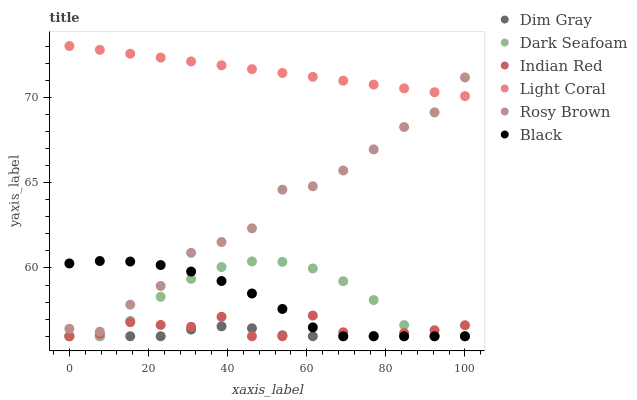Does Dim Gray have the minimum area under the curve?
Answer yes or no. Yes. Does Light Coral have the maximum area under the curve?
Answer yes or no. Yes. Does Rosy Brown have the minimum area under the curve?
Answer yes or no. No. Does Rosy Brown have the maximum area under the curve?
Answer yes or no. No. Is Light Coral the smoothest?
Answer yes or no. Yes. Is Rosy Brown the roughest?
Answer yes or no. Yes. Is Rosy Brown the smoothest?
Answer yes or no. No. Is Light Coral the roughest?
Answer yes or no. No. Does Dim Gray have the lowest value?
Answer yes or no. Yes. Does Rosy Brown have the lowest value?
Answer yes or no. No. Does Light Coral have the highest value?
Answer yes or no. Yes. Does Rosy Brown have the highest value?
Answer yes or no. No. Is Dim Gray less than Rosy Brown?
Answer yes or no. Yes. Is Rosy Brown greater than Indian Red?
Answer yes or no. Yes. Does Black intersect Dark Seafoam?
Answer yes or no. Yes. Is Black less than Dark Seafoam?
Answer yes or no. No. Is Black greater than Dark Seafoam?
Answer yes or no. No. Does Dim Gray intersect Rosy Brown?
Answer yes or no. No. 